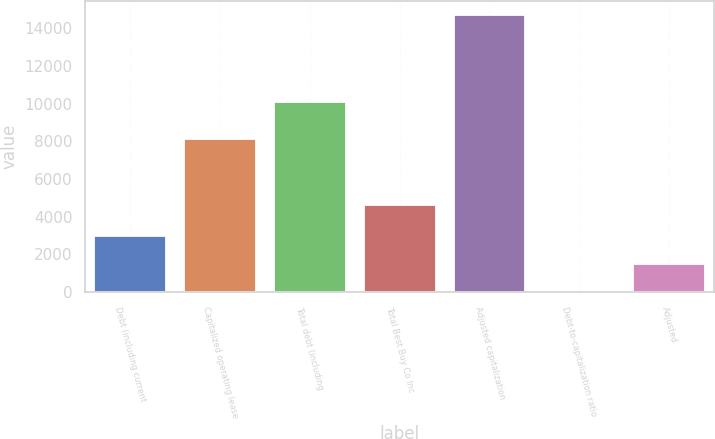Convert chart. <chart><loc_0><loc_0><loc_500><loc_500><bar_chart><fcel>Debt (including current<fcel>Capitalized operating lease<fcel>Total debt (including<fcel>Total Best Buy Co Inc<fcel>Adjusted capitalization<fcel>Debt-to-capitalization ratio<fcel>Adjusted<nl><fcel>2968<fcel>8114<fcel>10077<fcel>4643<fcel>14720<fcel>30<fcel>1499<nl></chart> 